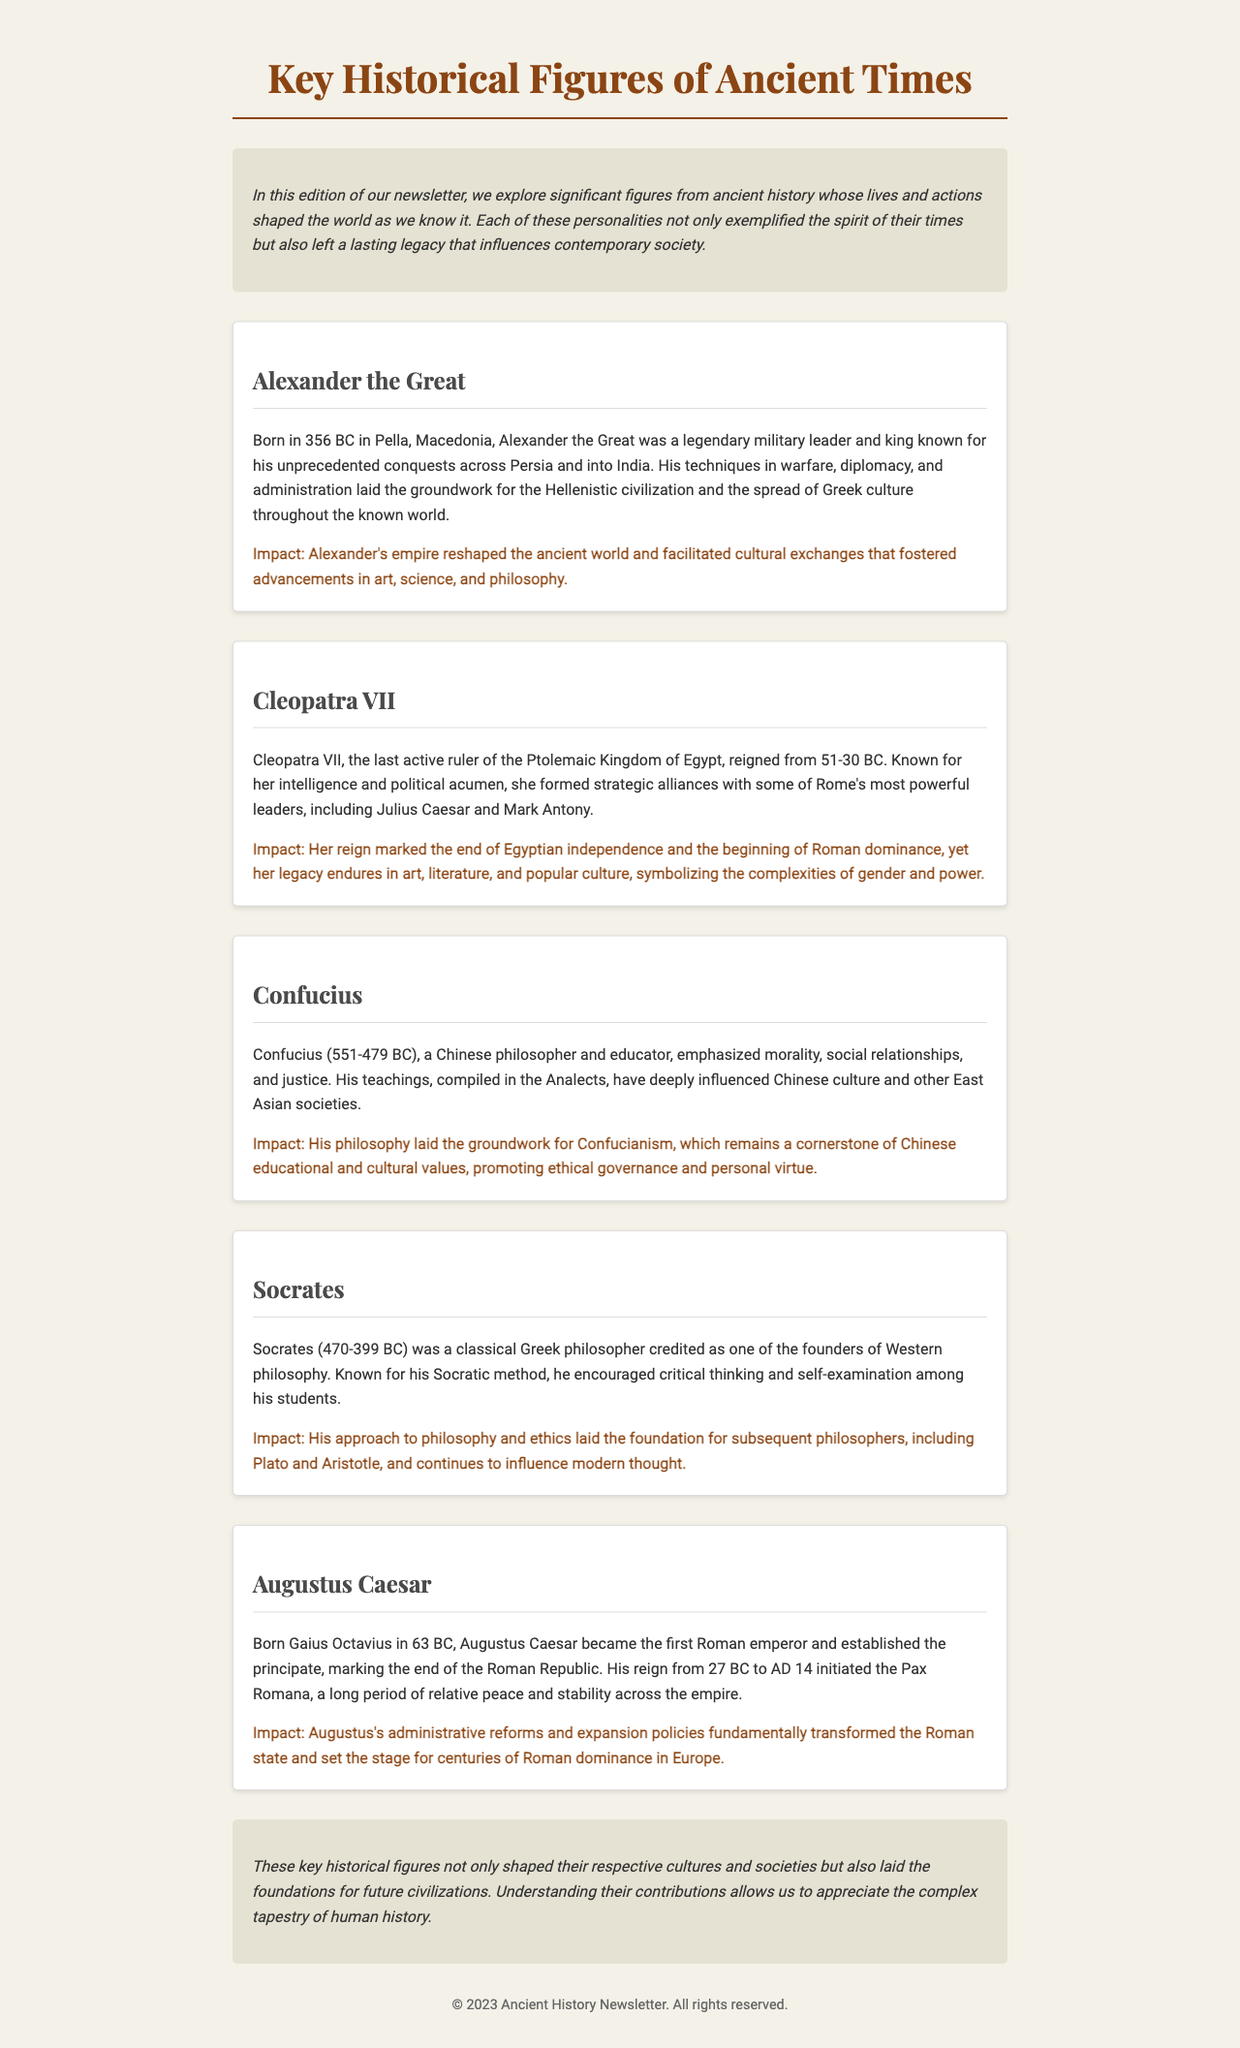What year was Alexander the Great born? The document states that Alexander the Great was born in 356 BC.
Answer: 356 BC Who formed strategic alliances with Julius Caesar? Cleopatra VII is noted in the document for forming alliances with powerful leaders such as Julius Caesar.
Answer: Cleopatra VII What is the title of Confucius's teachings? The teachings of Confucius are compiled in a work called the Analects.
Answer: Analects What was the period of relative peace initiated by Augustus Caesar? The period initiated by Augustus Caesar is known as the Pax Romana, which is mentioned in the context of his reign.
Answer: Pax Romana What impact did Socrates have on philosophy? Socrates laid the foundation for subsequent philosophers, including Plato and Aristotle, as described in the document.
Answer: Foundation for philosophy How long did Cleopatra VII reign? The document mentions that Cleopatra VII reigned from 51-30 BC, indicating a duration of 21 years.
Answer: 21 years What was the main focus of Confucius's philosophy? The document highlights that Confucius emphasized morality, social relationships, and justice.
Answer: Morality, social relationships, and justice Who was the first Roman emperor? The document identifies Augustus Caesar as the first Roman emperor, marking the transformation of the Roman Republic.
Answer: Augustus Caesar What type of document is this newsletter? The newsletter features biographies and impacts of key historical figures from ancient times.
Answer: Newsletter 